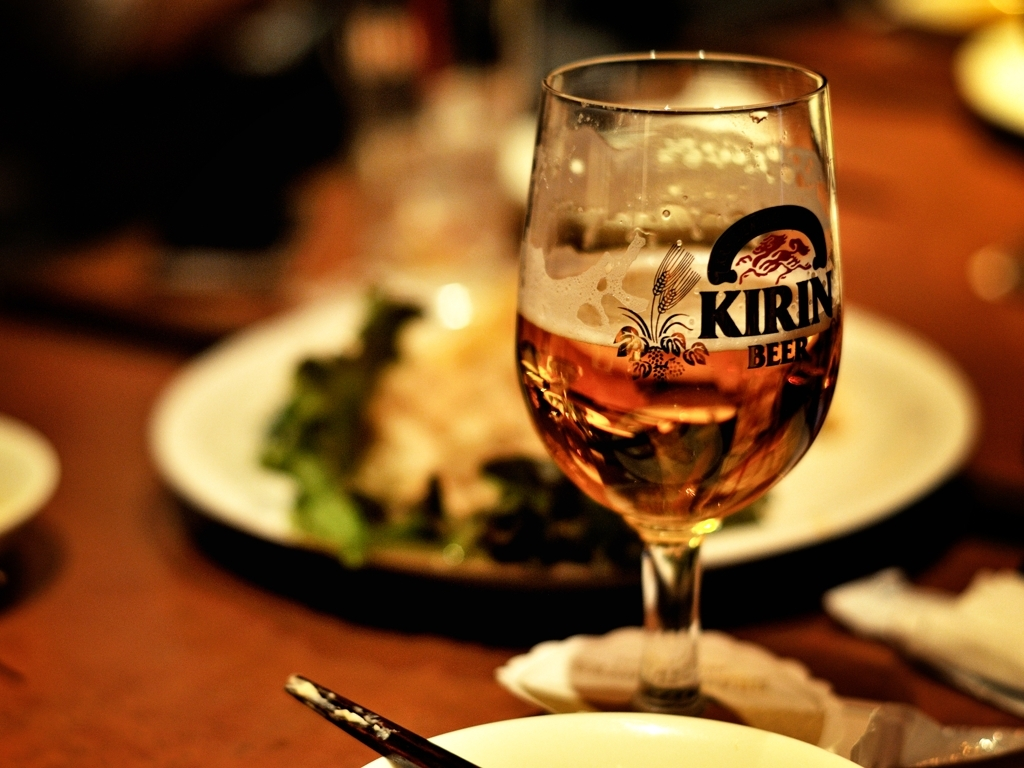What can you infer about the drink in the glass? The glass contains a golden-brown liquid, likely beer, as indicated by the label on the glass. The remaining foam at the top suggests the drink was recently poured and is possibly still cold. 